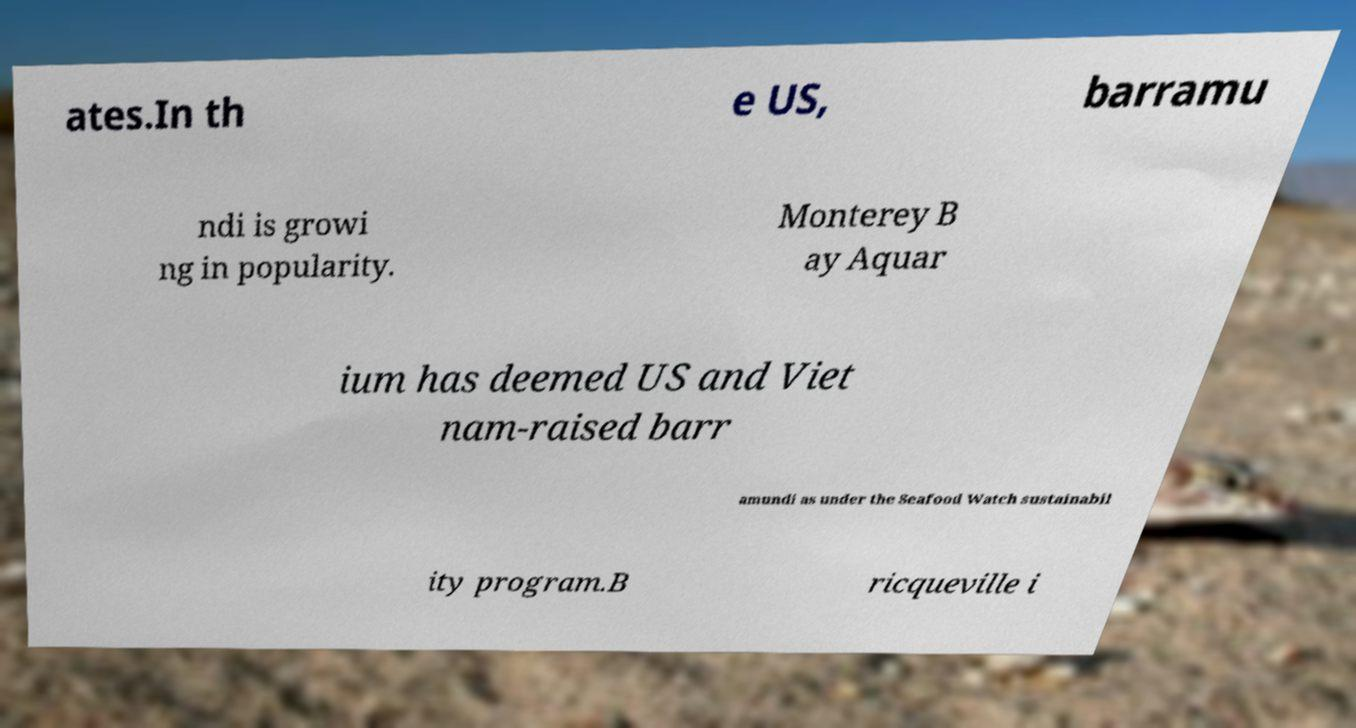I need the written content from this picture converted into text. Can you do that? ates.In th e US, barramu ndi is growi ng in popularity. Monterey B ay Aquar ium has deemed US and Viet nam-raised barr amundi as under the Seafood Watch sustainabil ity program.B ricqueville i 